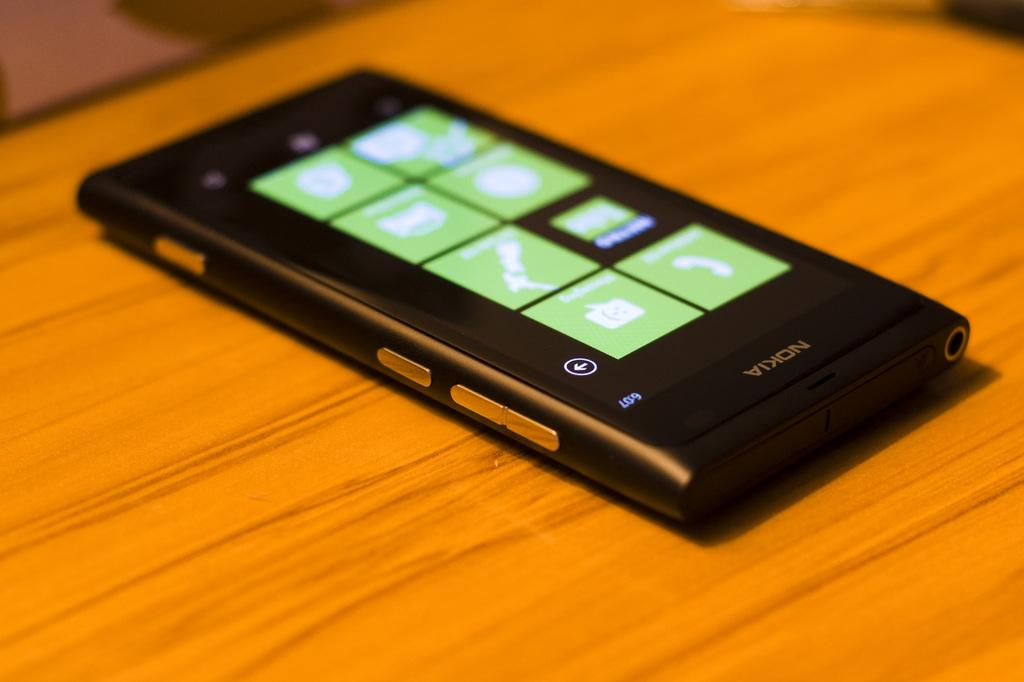Provide a one-sentence caption for the provided image. a black and silver nokia phone with the message app on the screen. 